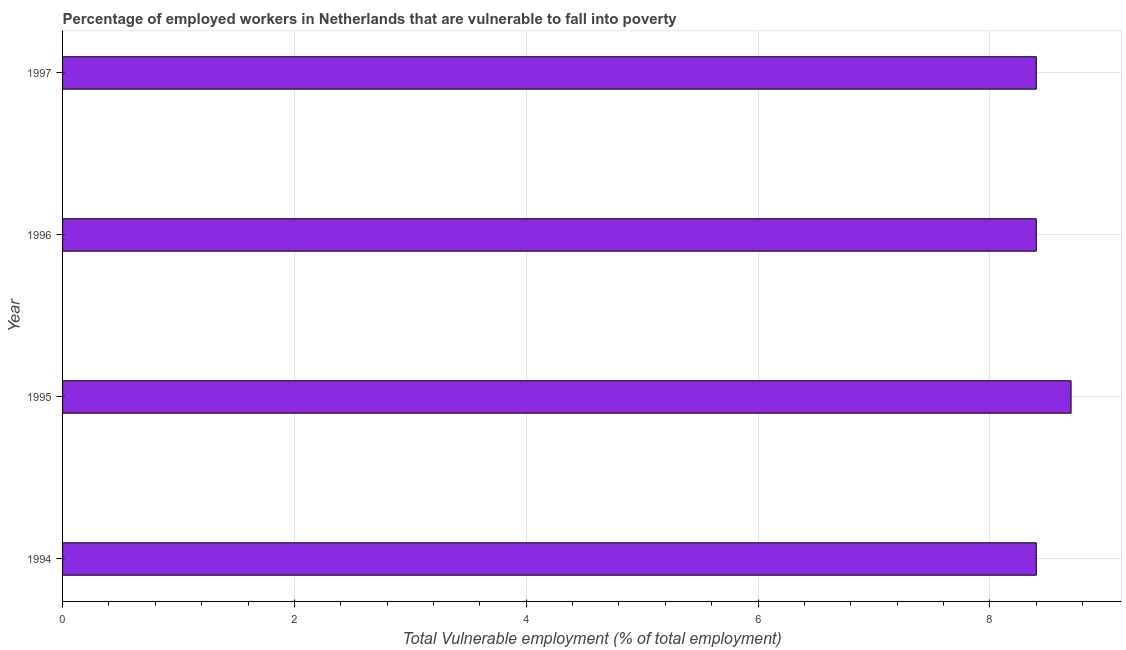What is the title of the graph?
Provide a short and direct response. Percentage of employed workers in Netherlands that are vulnerable to fall into poverty. What is the label or title of the X-axis?
Keep it short and to the point. Total Vulnerable employment (% of total employment). What is the label or title of the Y-axis?
Offer a very short reply. Year. What is the total vulnerable employment in 1997?
Your response must be concise. 8.4. Across all years, what is the maximum total vulnerable employment?
Keep it short and to the point. 8.7. Across all years, what is the minimum total vulnerable employment?
Provide a short and direct response. 8.4. What is the sum of the total vulnerable employment?
Provide a short and direct response. 33.9. What is the average total vulnerable employment per year?
Your answer should be very brief. 8.47. What is the median total vulnerable employment?
Keep it short and to the point. 8.4. In how many years, is the total vulnerable employment greater than 2.8 %?
Make the answer very short. 4. What is the ratio of the total vulnerable employment in 1994 to that in 1996?
Provide a succinct answer. 1. Is the difference between the total vulnerable employment in 1994 and 1996 greater than the difference between any two years?
Your answer should be very brief. No. What is the difference between the highest and the lowest total vulnerable employment?
Offer a very short reply. 0.3. In how many years, is the total vulnerable employment greater than the average total vulnerable employment taken over all years?
Your answer should be very brief. 1. Are all the bars in the graph horizontal?
Offer a terse response. Yes. How many years are there in the graph?
Offer a terse response. 4. What is the difference between two consecutive major ticks on the X-axis?
Your answer should be very brief. 2. Are the values on the major ticks of X-axis written in scientific E-notation?
Give a very brief answer. No. What is the Total Vulnerable employment (% of total employment) of 1994?
Make the answer very short. 8.4. What is the Total Vulnerable employment (% of total employment) in 1995?
Provide a short and direct response. 8.7. What is the Total Vulnerable employment (% of total employment) in 1996?
Ensure brevity in your answer.  8.4. What is the Total Vulnerable employment (% of total employment) in 1997?
Offer a very short reply. 8.4. What is the difference between the Total Vulnerable employment (% of total employment) in 1994 and 1995?
Offer a very short reply. -0.3. What is the difference between the Total Vulnerable employment (% of total employment) in 1994 and 1996?
Provide a succinct answer. 0. What is the difference between the Total Vulnerable employment (% of total employment) in 1994 and 1997?
Your response must be concise. 0. What is the difference between the Total Vulnerable employment (% of total employment) in 1995 and 1997?
Provide a succinct answer. 0.3. What is the difference between the Total Vulnerable employment (% of total employment) in 1996 and 1997?
Your answer should be very brief. 0. What is the ratio of the Total Vulnerable employment (% of total employment) in 1994 to that in 1996?
Ensure brevity in your answer.  1. What is the ratio of the Total Vulnerable employment (% of total employment) in 1994 to that in 1997?
Offer a terse response. 1. What is the ratio of the Total Vulnerable employment (% of total employment) in 1995 to that in 1996?
Make the answer very short. 1.04. What is the ratio of the Total Vulnerable employment (% of total employment) in 1995 to that in 1997?
Your response must be concise. 1.04. What is the ratio of the Total Vulnerable employment (% of total employment) in 1996 to that in 1997?
Keep it short and to the point. 1. 